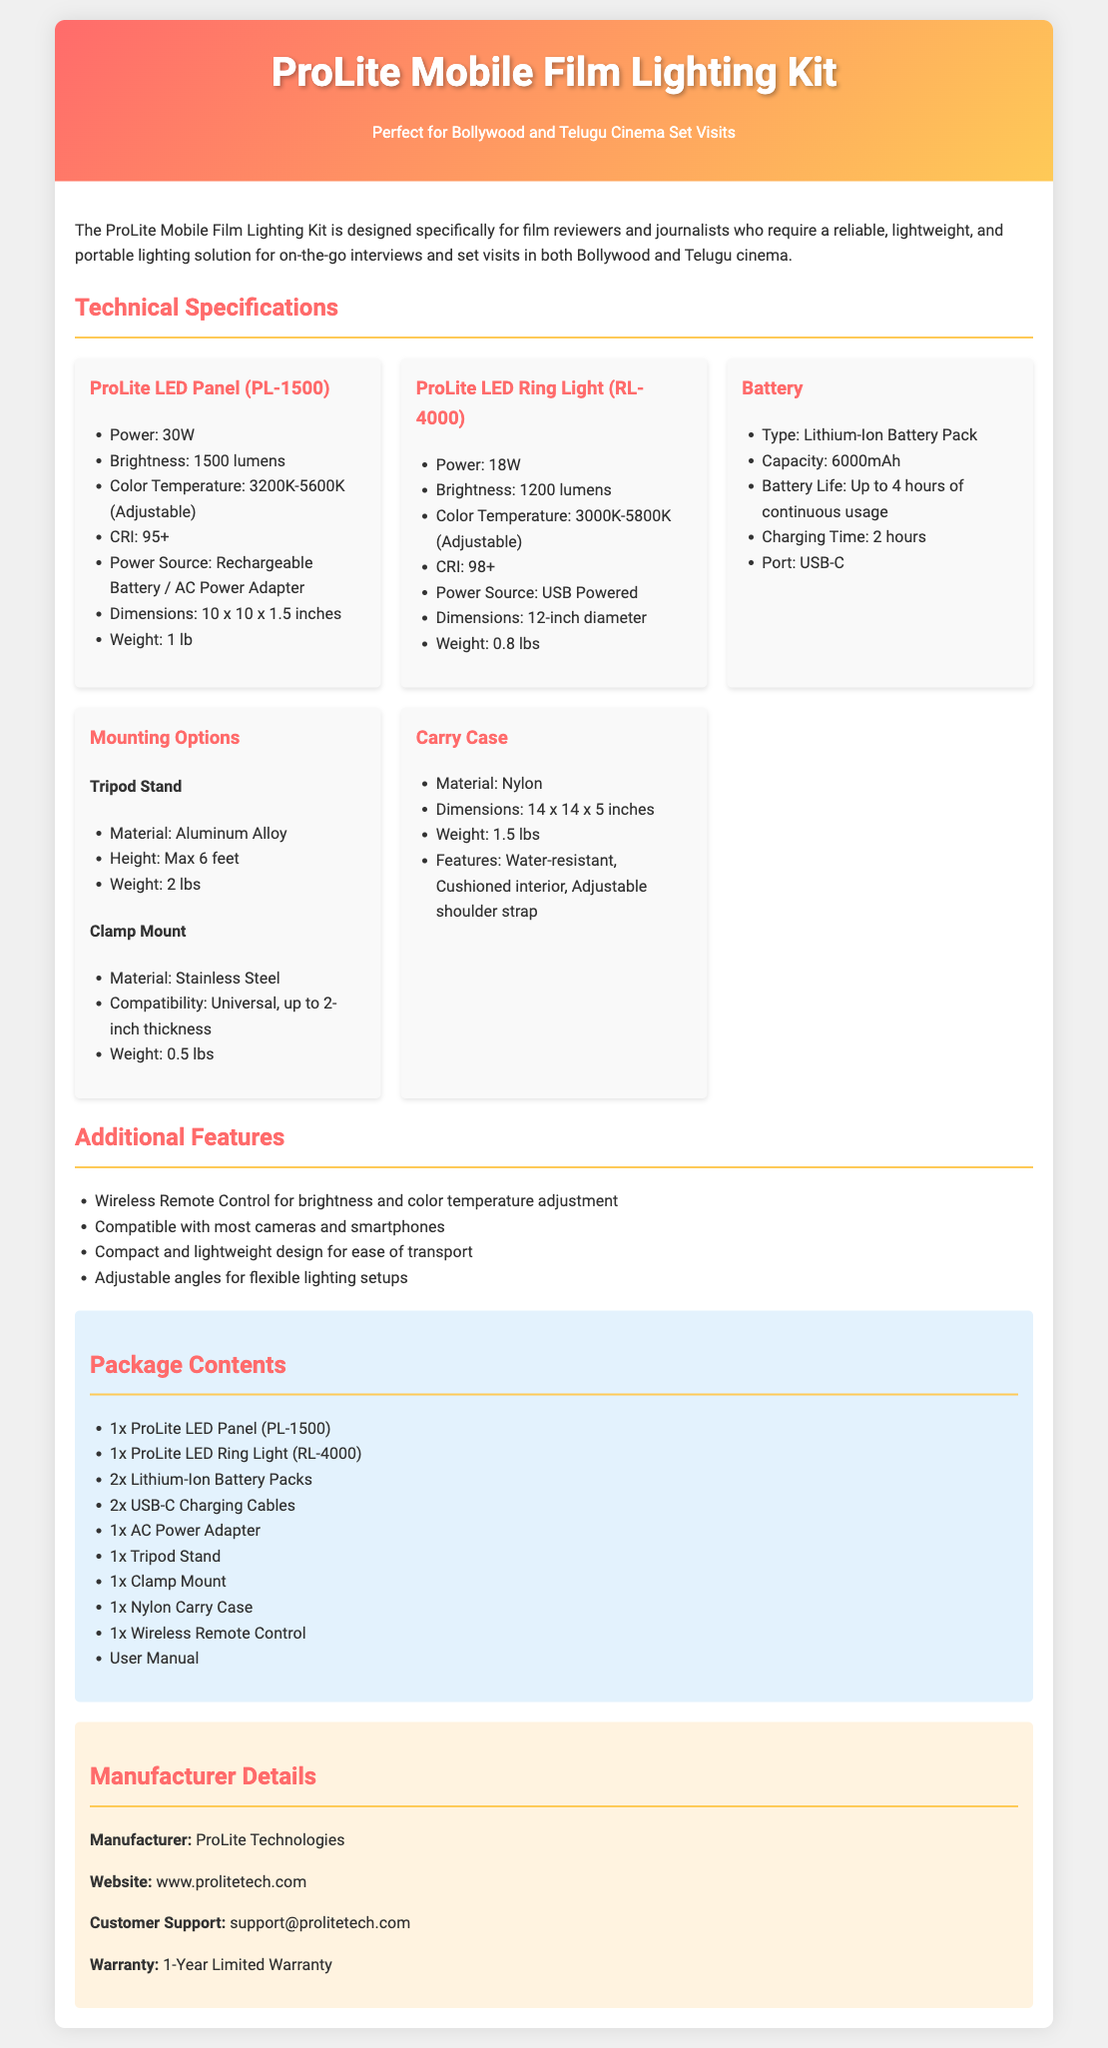What is the power of the ProLite LED Panel? The power of the ProLite LED Panel (PL-1500) is specified in the document under its technical specifications.
Answer: 30W What is the weight of the ProLite LED Ring Light? The weight of the ProLite LED Ring Light (RL-4000) is included in the specifications for that item.
Answer: 0.8 lbs What is the battery life of the Lithium-Ion Battery Pack? The battery life is listed in the specifications of the Battery section, indicating how long it can be used continuously.
Answer: Up to 4 hours What is the maximum height of the Tripod Stand? The maximum height of the Tripod Stand can be found in the Mounting Options section under specifications.
Answer: Max 6 feet Who is the manufacturer of the ProLite Mobile Film Lighting Kit? The manufacturer information is provided in the Manufacturer Details section of the document.
Answer: ProLite Technologies What is the color temperature range of the ProLite LED Panel? The color temperature range is stated in the specifications of the ProLite LED Panel (PL-1500) section.
Answer: 3200K-5600K (Adjustable) How many Lithium-Ion Battery Packs are included in the package? The number of Lithium-Ion Battery Packs included can be found in the Package Contents section of the document.
Answer: 2 What is the power source for the ProLite LED Ring Light? The power source for the ProLite LED Ring Light (RL-4000) is mentioned in its specifications.
Answer: USB Powered What features does the Carry Case have? The features of the Carry Case are detailed in the specifications of that item in the document.
Answer: Water-resistant, Cushioned interior, Adjustable shoulder strap 